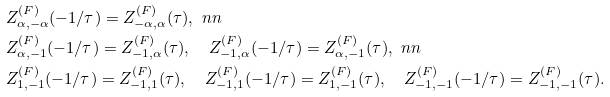<formula> <loc_0><loc_0><loc_500><loc_500>& Z ^ { ( F ) } _ { \alpha , - \alpha } ( - 1 / \tau ) = Z ^ { ( F ) } _ { - \alpha , \alpha } ( \tau ) , \ n n \\ & Z ^ { ( F ) } _ { \alpha , - 1 } ( - 1 / \tau ) = Z ^ { ( F ) } _ { - 1 , \alpha } ( \tau ) , \quad Z ^ { ( F ) } _ { - 1 , \alpha } ( - 1 / \tau ) = Z ^ { ( F ) } _ { \alpha , - 1 } ( \tau ) , \ n n \\ & Z ^ { ( F ) } _ { 1 , - 1 } ( - 1 / \tau ) = Z ^ { ( F ) } _ { - 1 , 1 } ( \tau ) , \quad Z ^ { ( F ) } _ { - 1 , 1 } ( - 1 / \tau ) = Z ^ { ( F ) } _ { 1 , - 1 } ( \tau ) , \quad Z ^ { ( F ) } _ { - 1 , - 1 } ( - 1 / \tau ) = Z ^ { ( F ) } _ { - 1 , - 1 } ( \tau ) .</formula> 